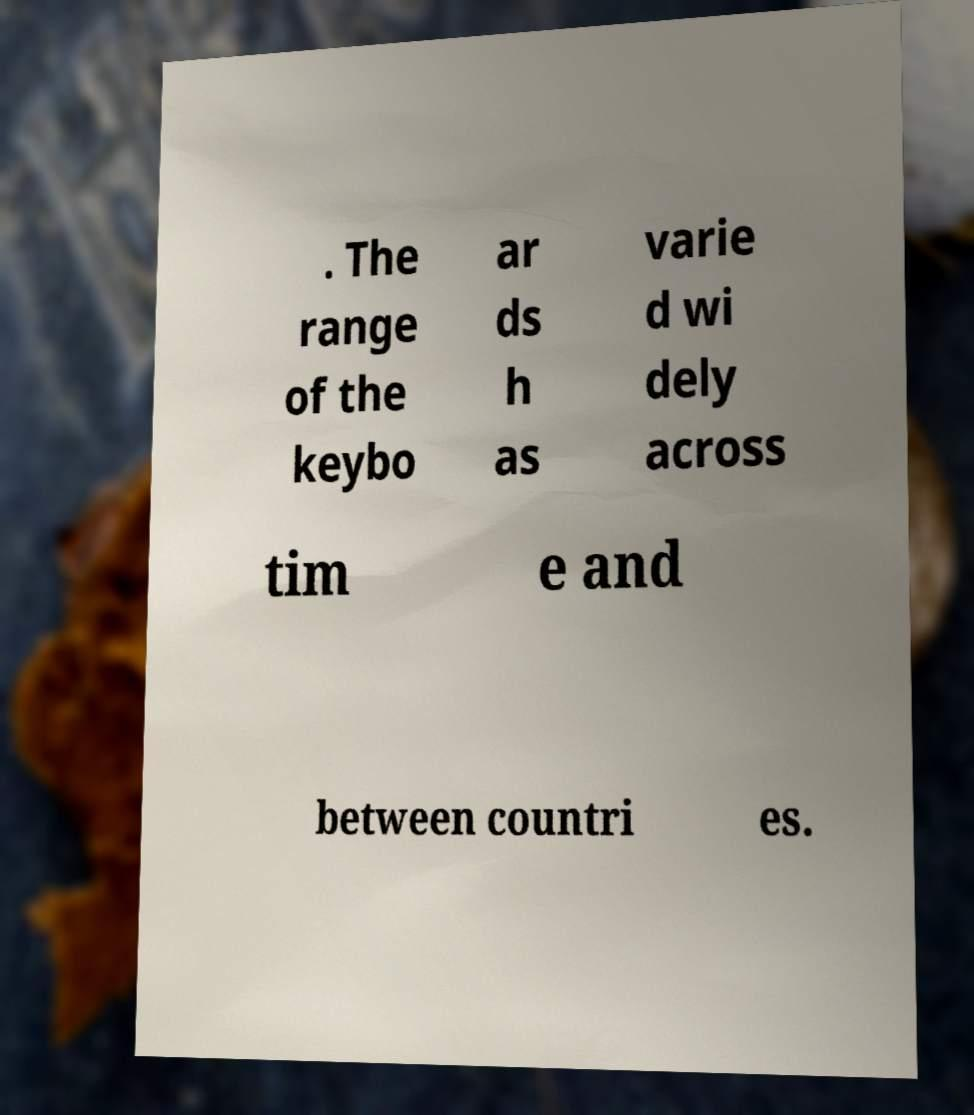Could you assist in decoding the text presented in this image and type it out clearly? . The range of the keybo ar ds h as varie d wi dely across tim e and between countri es. 